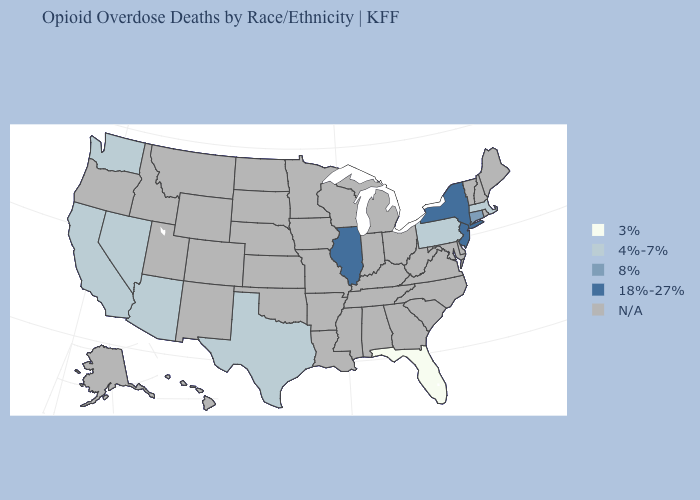Name the states that have a value in the range 4%-7%?
Be succinct. Arizona, California, Massachusetts, Nevada, Pennsylvania, Texas, Washington. What is the value of Illinois?
Short answer required. 18%-27%. Does Florida have the lowest value in the USA?
Concise answer only. Yes. Name the states that have a value in the range 18%-27%?
Keep it brief. Illinois, New Jersey, New York. What is the lowest value in the MidWest?
Short answer required. 18%-27%. Which states have the lowest value in the USA?
Answer briefly. Florida. Does the map have missing data?
Concise answer only. Yes. Name the states that have a value in the range N/A?
Concise answer only. Alabama, Alaska, Arkansas, Colorado, Delaware, Georgia, Hawaii, Idaho, Indiana, Iowa, Kansas, Kentucky, Louisiana, Maine, Maryland, Michigan, Minnesota, Mississippi, Missouri, Montana, Nebraska, New Hampshire, New Mexico, North Carolina, North Dakota, Ohio, Oklahoma, Oregon, Rhode Island, South Carolina, South Dakota, Tennessee, Utah, Vermont, Virginia, West Virginia, Wisconsin, Wyoming. What is the value of Pennsylvania?
Quick response, please. 4%-7%. Among the states that border Nevada , which have the lowest value?
Concise answer only. Arizona, California. Which states have the lowest value in the South?
Keep it brief. Florida. What is the lowest value in the MidWest?
Keep it brief. 18%-27%. 